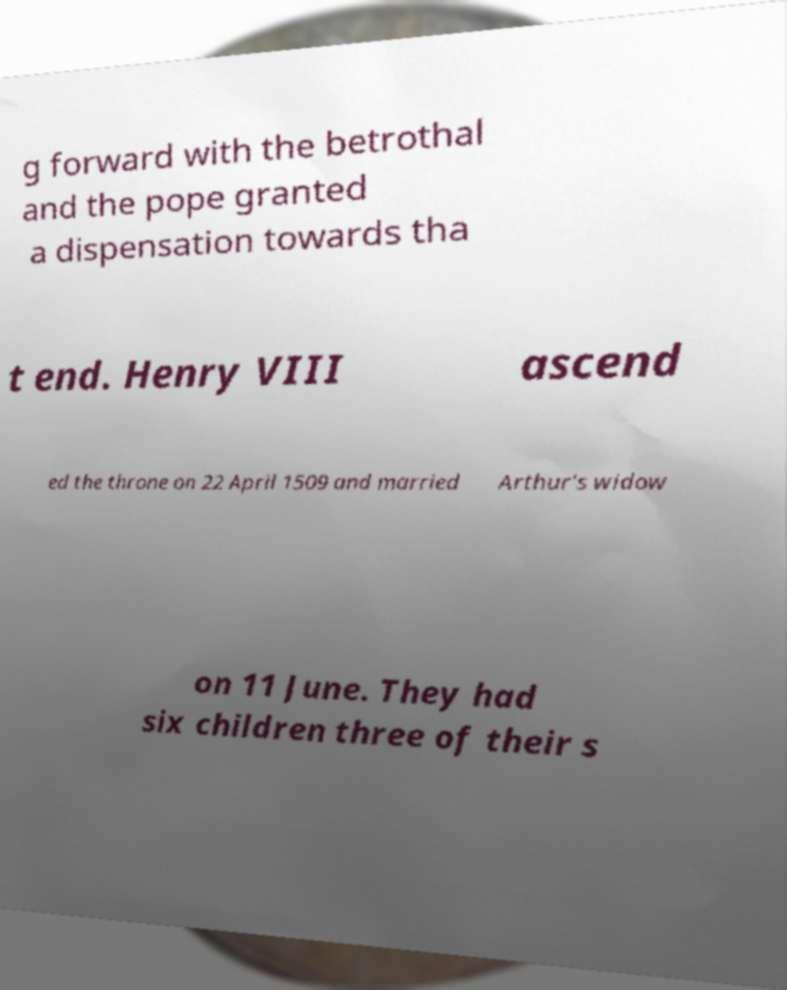I need the written content from this picture converted into text. Can you do that? g forward with the betrothal and the pope granted a dispensation towards tha t end. Henry VIII ascend ed the throne on 22 April 1509 and married Arthur's widow on 11 June. They had six children three of their s 